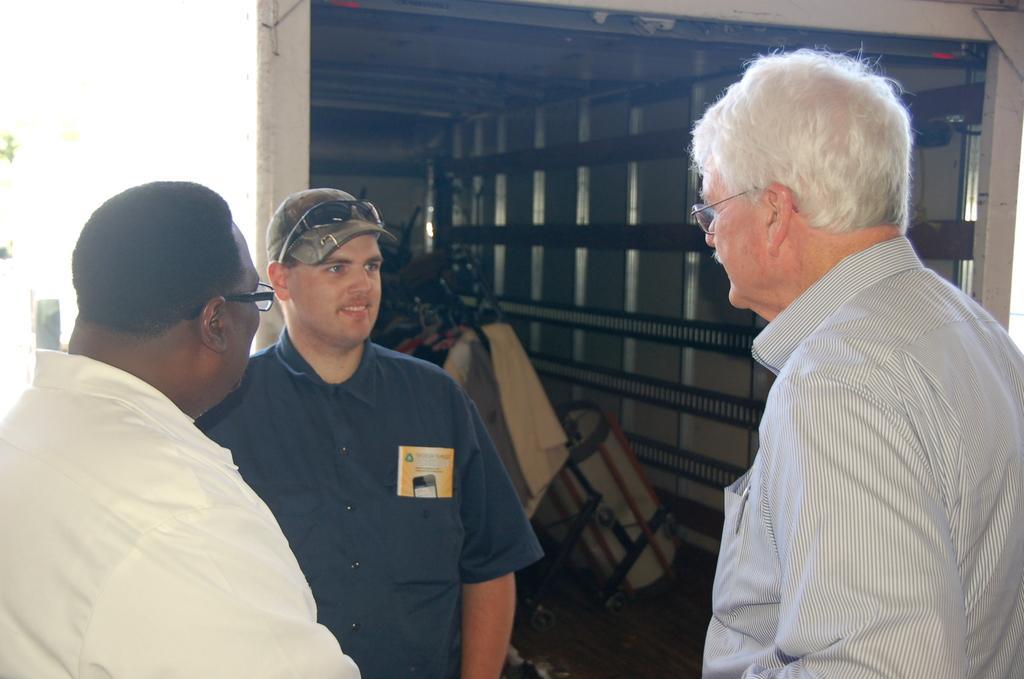In one or two sentences, can you explain what this image depicts? In this image we can see three men standing. On the backside we can see some objects placed inside a truck. 